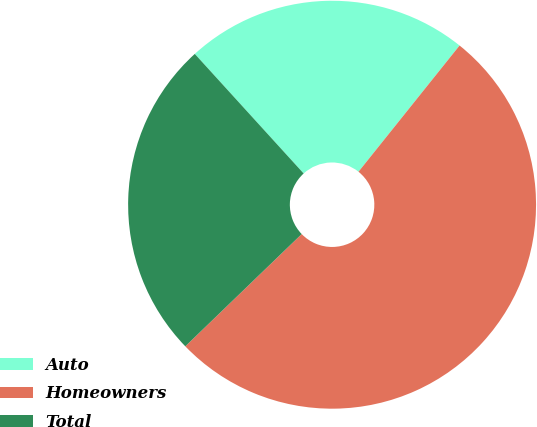Convert chart to OTSL. <chart><loc_0><loc_0><loc_500><loc_500><pie_chart><fcel>Auto<fcel>Homeowners<fcel>Total<nl><fcel>22.5%<fcel>52.04%<fcel>25.46%<nl></chart> 